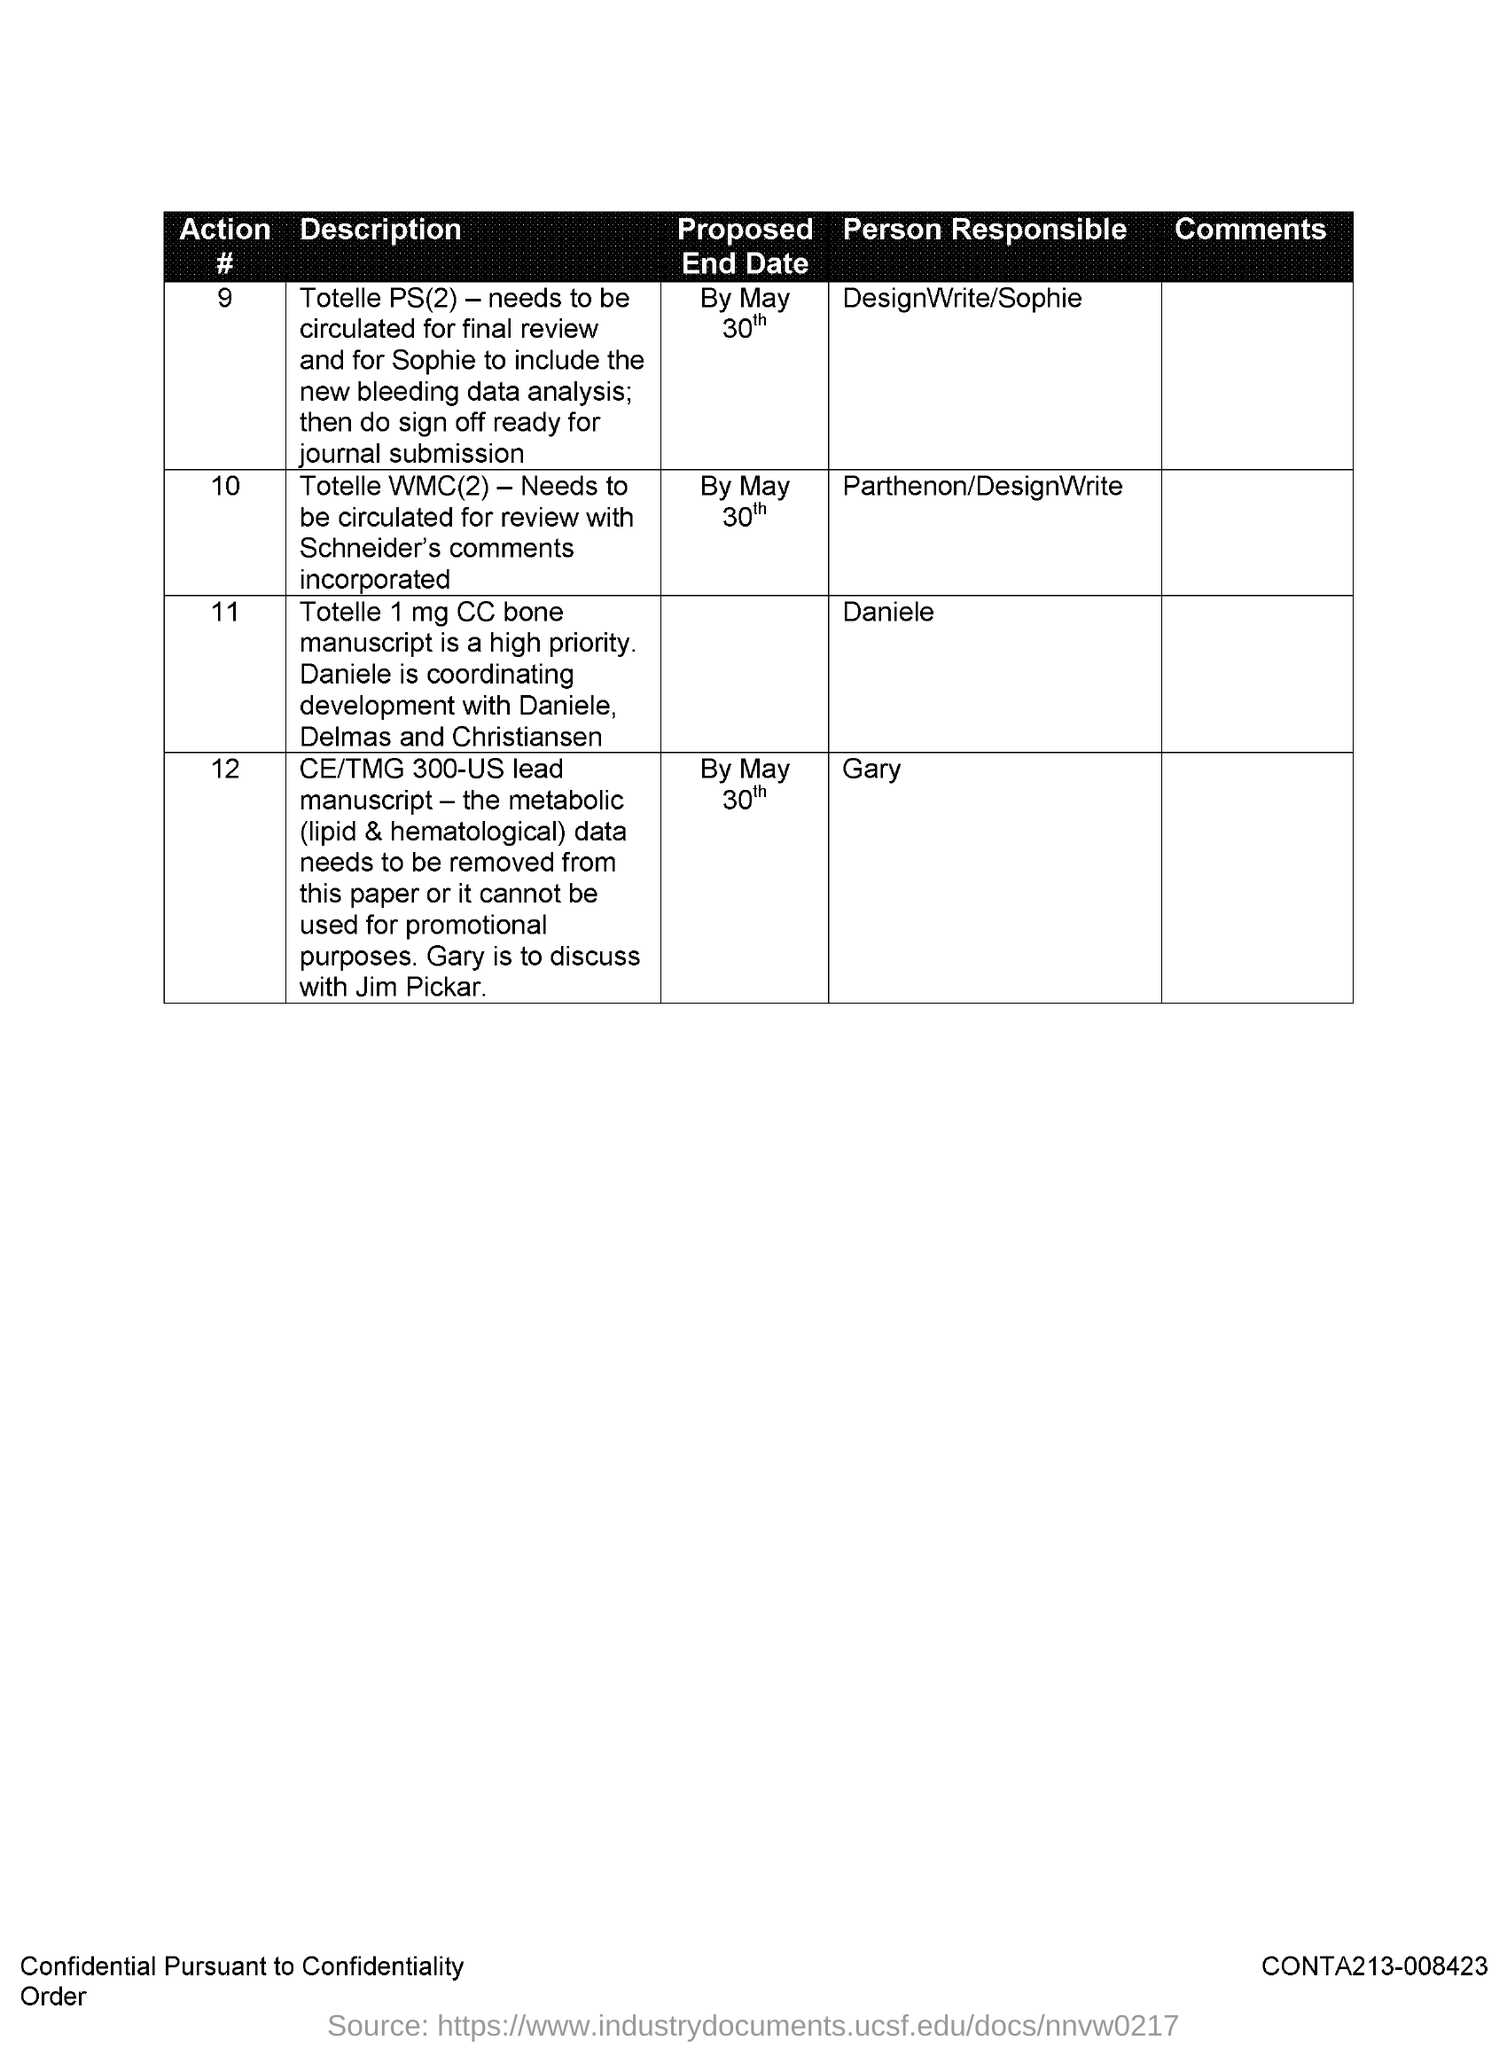Who is responsible for action number 10?
Ensure brevity in your answer.  Parthenon/DesignWrite. Who is responsible for action number 11?
Offer a terse response. Daniele. Who is responsible for action number 12?
Give a very brief answer. Gary. What is the Proposed End date of Action #9?
Provide a short and direct response. By May 30th. What is the Proposed End date of Action #10?
Provide a short and direct response. By May 30th. 